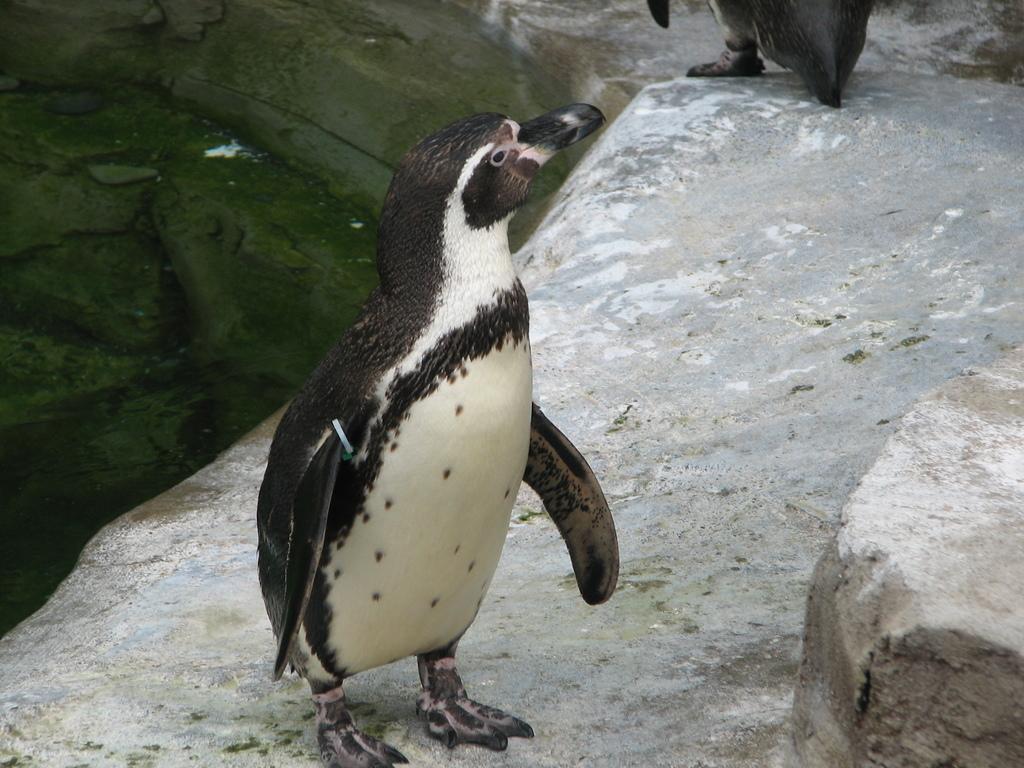Could you give a brief overview of what you see in this image? In this image, there are penguins on a rock. 